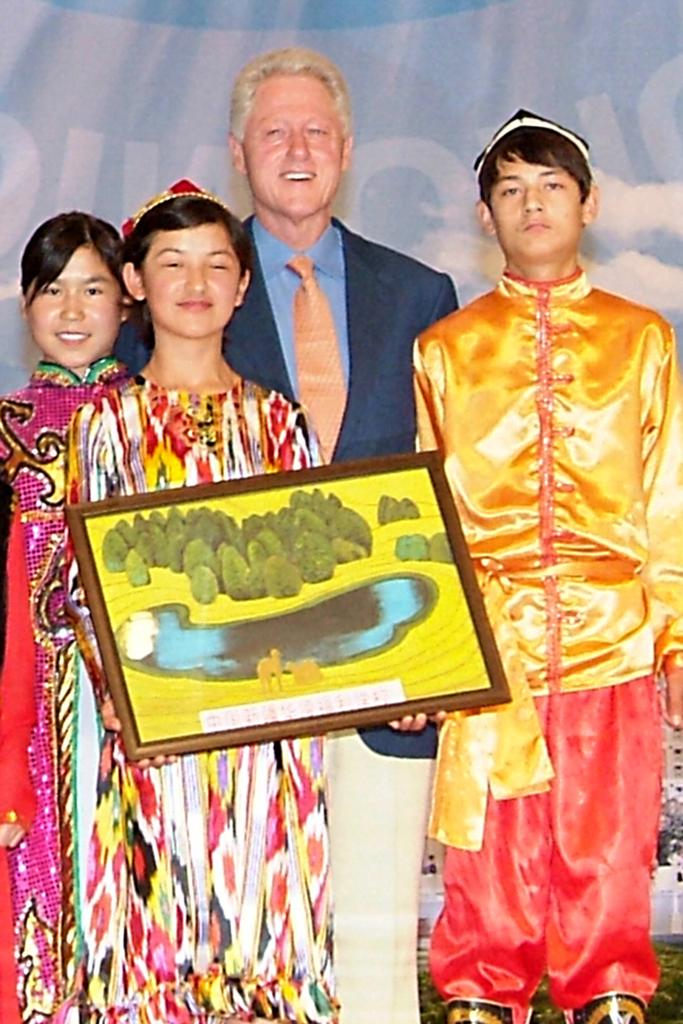What are the people in the image doing? The persons in the image are standing on the ground. Can you describe what one of the persons is holding? One of the persons is holding a photo frame in their hands. What type of crate is visible in the scene with the persons? There is no crate present in the image; it only shows persons standing on the ground and one holding a photo frame. 